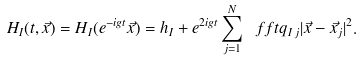Convert formula to latex. <formula><loc_0><loc_0><loc_500><loc_500>H _ { I } ( t , \vec { x } ) = H _ { I } ( e ^ { - i g t } \vec { x } ) = h _ { I } + e ^ { 2 i g t } \sum _ { j = 1 } ^ { N } \ f f t { q _ { I \, j } } { | \vec { x } - \vec { x } _ { j } | ^ { 2 } } .</formula> 